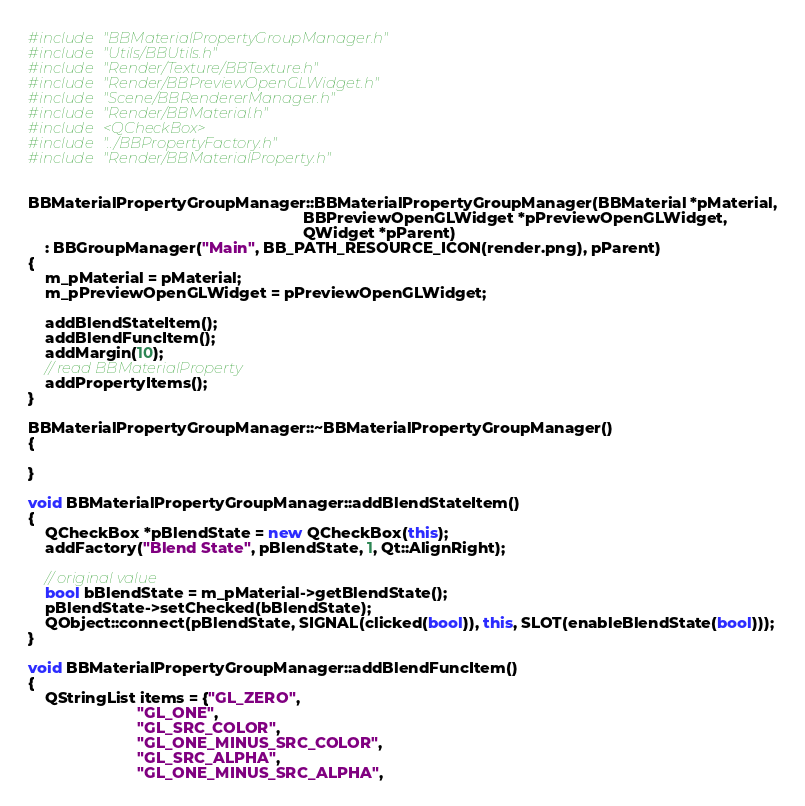<code> <loc_0><loc_0><loc_500><loc_500><_C++_>#include "BBMaterialPropertyGroupManager.h"
#include "Utils/BBUtils.h"
#include "Render/Texture/BBTexture.h"
#include "Render/BBPreviewOpenGLWidget.h"
#include "Scene/BBRendererManager.h"
#include "Render/BBMaterial.h"
#include <QCheckBox>
#include "../BBPropertyFactory.h"
#include "Render/BBMaterialProperty.h"


BBMaterialPropertyGroupManager::BBMaterialPropertyGroupManager(BBMaterial *pMaterial,
                                                               BBPreviewOpenGLWidget *pPreviewOpenGLWidget,
                                                               QWidget *pParent)
    : BBGroupManager("Main", BB_PATH_RESOURCE_ICON(render.png), pParent)
{
    m_pMaterial = pMaterial;
    m_pPreviewOpenGLWidget = pPreviewOpenGLWidget;

    addBlendStateItem();
    addBlendFuncItem();
    addMargin(10);
    // read BBMaterialProperty
    addPropertyItems();
}

BBMaterialPropertyGroupManager::~BBMaterialPropertyGroupManager()
{

}

void BBMaterialPropertyGroupManager::addBlendStateItem()
{
    QCheckBox *pBlendState = new QCheckBox(this);
    addFactory("Blend State", pBlendState, 1, Qt::AlignRight);

    // original value
    bool bBlendState = m_pMaterial->getBlendState();
    pBlendState->setChecked(bBlendState);
    QObject::connect(pBlendState, SIGNAL(clicked(bool)), this, SLOT(enableBlendState(bool)));
}

void BBMaterialPropertyGroupManager::addBlendFuncItem()
{
    QStringList items = {"GL_ZERO",
                         "GL_ONE",
                         "GL_SRC_COLOR",
                         "GL_ONE_MINUS_SRC_COLOR",
                         "GL_SRC_ALPHA",
                         "GL_ONE_MINUS_SRC_ALPHA",</code> 